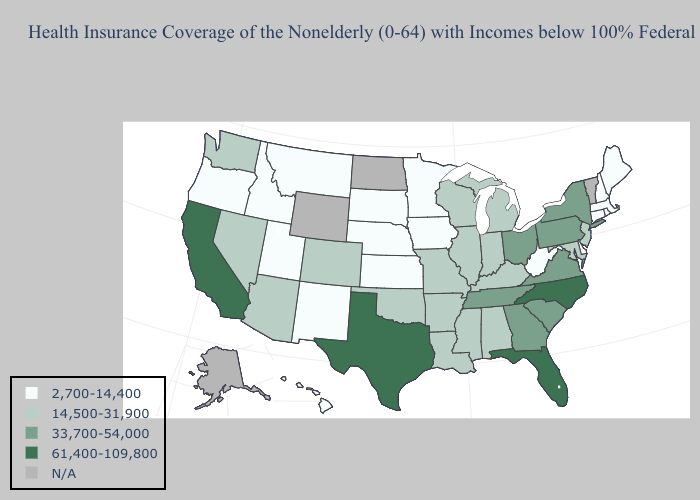Which states have the lowest value in the USA?
Answer briefly. Connecticut, Delaware, Hawaii, Idaho, Iowa, Kansas, Maine, Massachusetts, Minnesota, Montana, Nebraska, New Hampshire, New Mexico, Oregon, Rhode Island, South Dakota, Utah, West Virginia. What is the value of Kansas?
Give a very brief answer. 2,700-14,400. Does Texas have the highest value in the USA?
Concise answer only. Yes. Which states hav the highest value in the South?
Be succinct. Florida, North Carolina, Texas. What is the value of New Hampshire?
Write a very short answer. 2,700-14,400. Among the states that border Utah , which have the lowest value?
Be succinct. Idaho, New Mexico. What is the value of Virginia?
Concise answer only. 33,700-54,000. Among the states that border North Carolina , which have the lowest value?
Quick response, please. Georgia, South Carolina, Tennessee, Virginia. Does West Virginia have the lowest value in the South?
Quick response, please. Yes. What is the value of Louisiana?
Concise answer only. 14,500-31,900. What is the value of Virginia?
Write a very short answer. 33,700-54,000. Name the states that have a value in the range 14,500-31,900?
Write a very short answer. Alabama, Arizona, Arkansas, Colorado, Illinois, Indiana, Kentucky, Louisiana, Maryland, Michigan, Mississippi, Missouri, Nevada, New Jersey, Oklahoma, Washington, Wisconsin. What is the highest value in states that border Tennessee?
Keep it brief. 61,400-109,800. Does North Carolina have the highest value in the USA?
Keep it brief. Yes. 